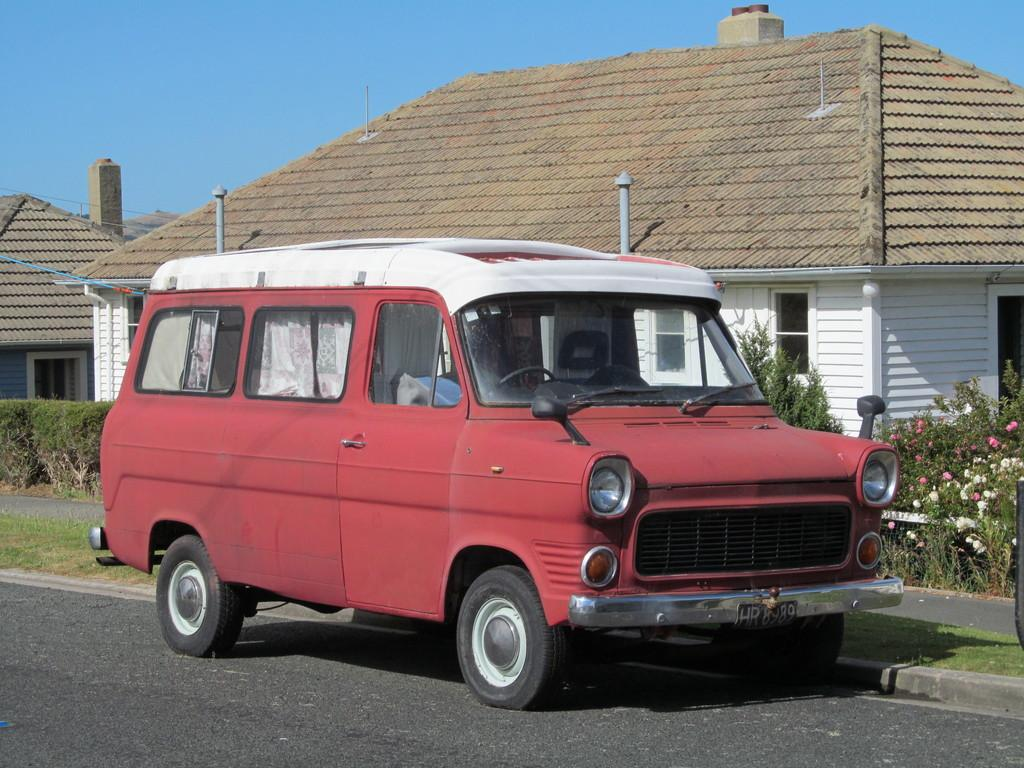What is the main subject of the image? There is a vehicle on the road in the image. What can be seen in the background of the image? There are seeds, plants, and flowers in the background of the image. What is visible at the top of the image? The sky is visible at the top of the image. What type of vegetation is present in the image? Hedges are present in the image. What type of suit can be seen hanging on the hedge in the image? There is no suit present in the image; it only features a vehicle, seeds, plants, flowers, and hedges. Can you hear a bell ringing in the image? There is no bell present in the image, so it is not possible to hear it ringing. 